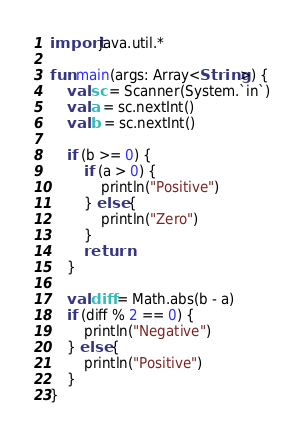Convert code to text. <code><loc_0><loc_0><loc_500><loc_500><_Kotlin_>import java.util.*
 
fun main(args: Array<String>) {
    val sc = Scanner(System.`in`)
    val a = sc.nextInt()
    val b = sc.nextInt()
 
    if (b >= 0) {
        if (a > 0) {
            println("Positive")
        } else {
            println("Zero")
        }
        return
    }
 
    val diff = Math.abs(b - a)
    if (diff % 2 == 0) {
        println("Negative")
    } else {
        println("Positive")
    }
}</code> 